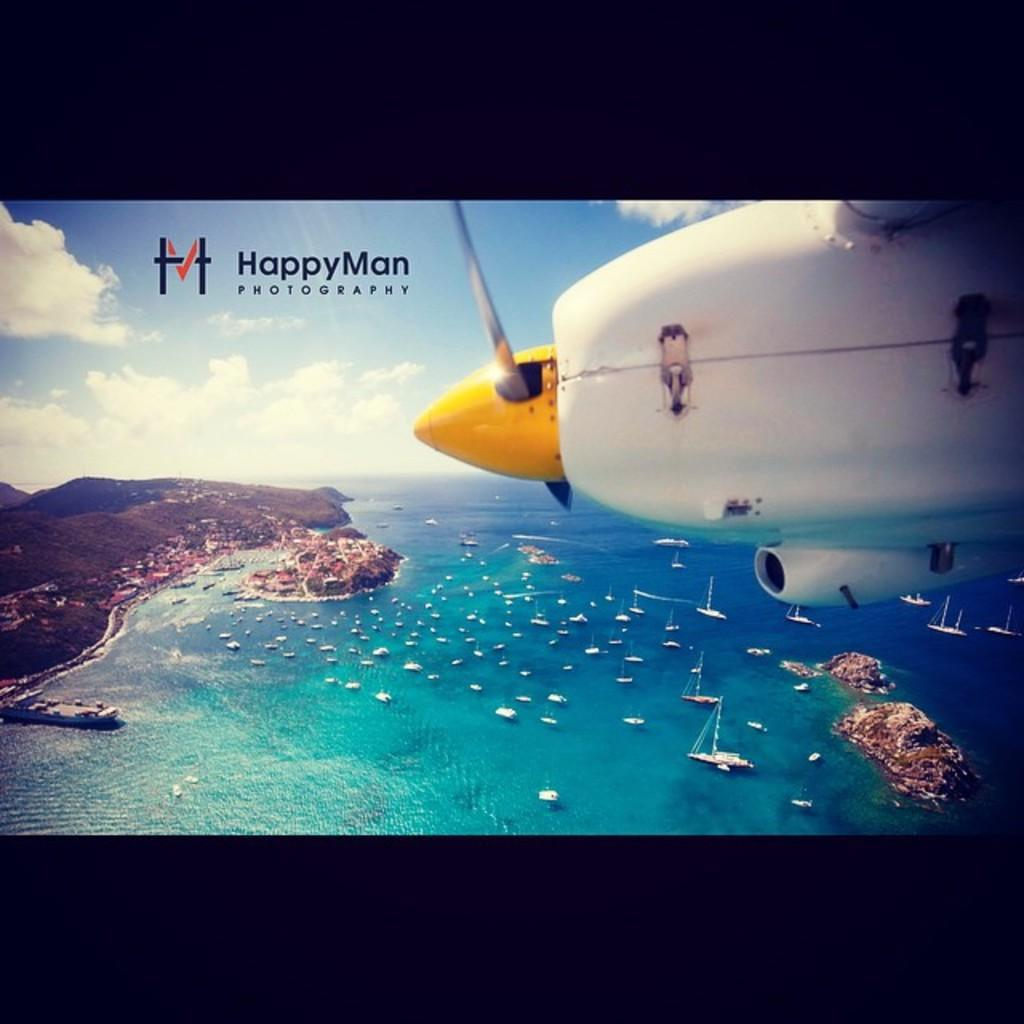What is the main subject of the image? There is an aircraft in the image. What else can be seen in the image besides the aircraft? There is text written on the image, boats in the water, a mountain, and the sky are visible. What type of credit can be seen being given to the aircraft in the image? There is no credit being given to the aircraft in the image; it is simply a visual representation. Can you see a coil of wire in the image? There is no coil of wire present in the image. 